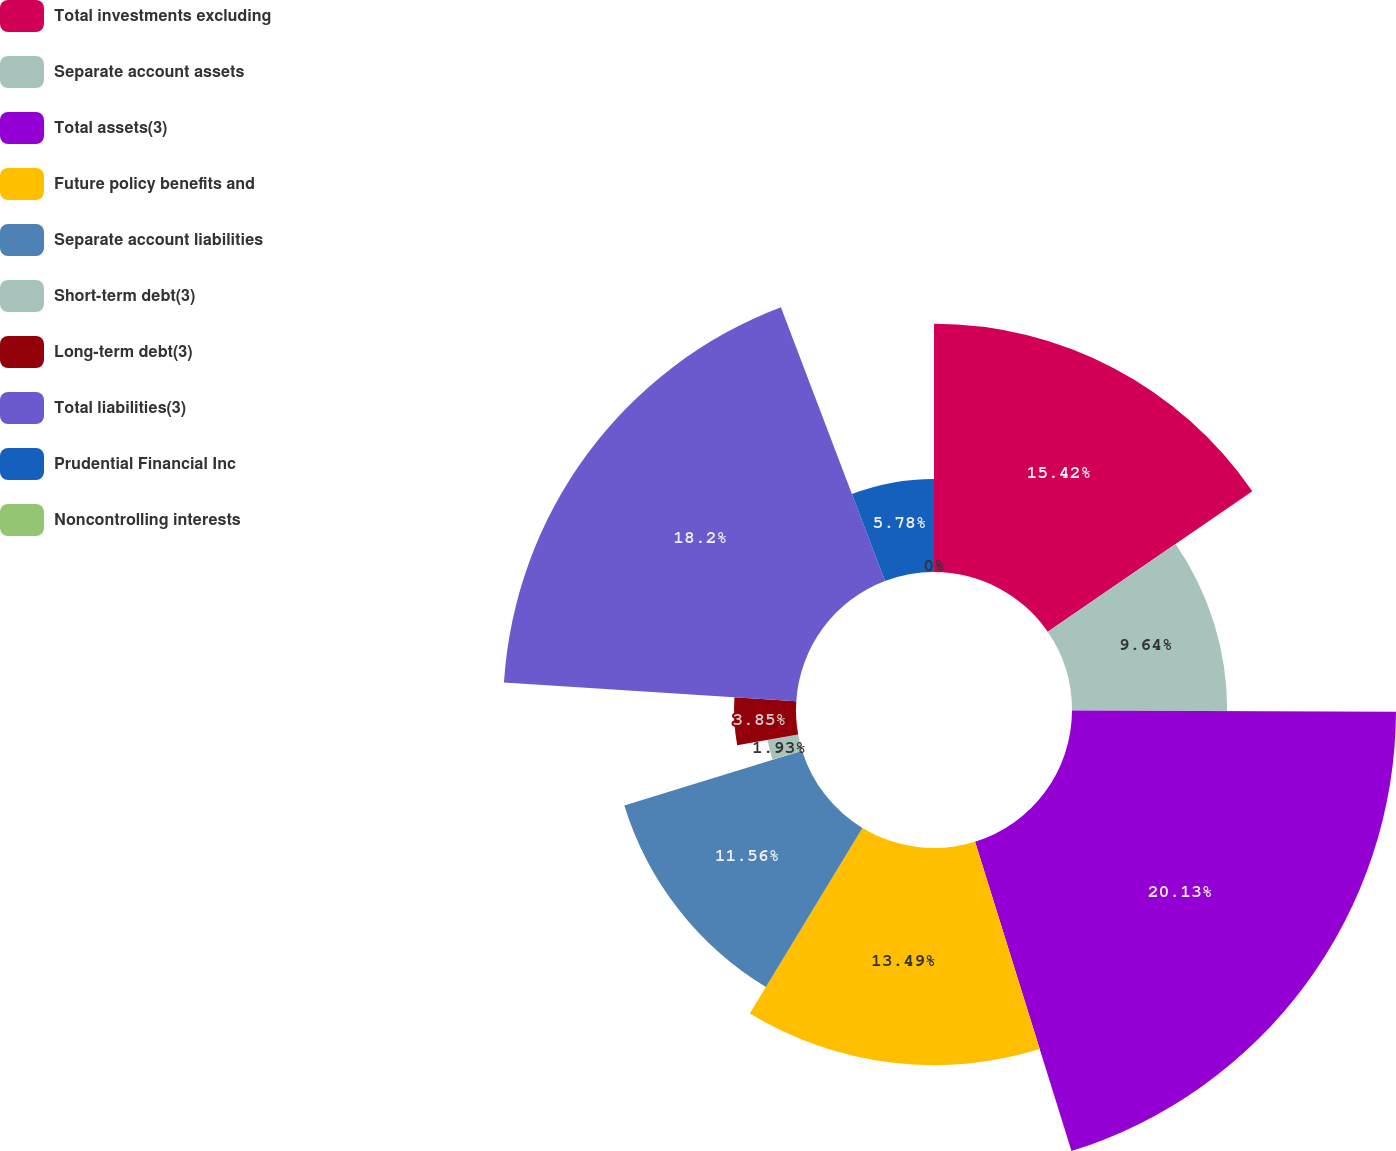<chart> <loc_0><loc_0><loc_500><loc_500><pie_chart><fcel>Total investments excluding<fcel>Separate account assets<fcel>Total assets(3)<fcel>Future policy benefits and<fcel>Separate account liabilities<fcel>Short-term debt(3)<fcel>Long-term debt(3)<fcel>Total liabilities(3)<fcel>Prudential Financial Inc<fcel>Noncontrolling interests<nl><fcel>15.42%<fcel>9.64%<fcel>20.13%<fcel>13.49%<fcel>11.56%<fcel>1.93%<fcel>3.85%<fcel>18.2%<fcel>5.78%<fcel>0.0%<nl></chart> 